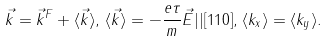<formula> <loc_0><loc_0><loc_500><loc_500>\vec { k } = \vec { k } ^ { F } + \langle \vec { k } \rangle , \, \langle \vec { k } \rangle = - \frac { e \tau } { m } \vec { E } | | [ 1 1 0 ] , \, \langle k _ { x } \rangle = \langle k _ { y } \rangle .</formula> 